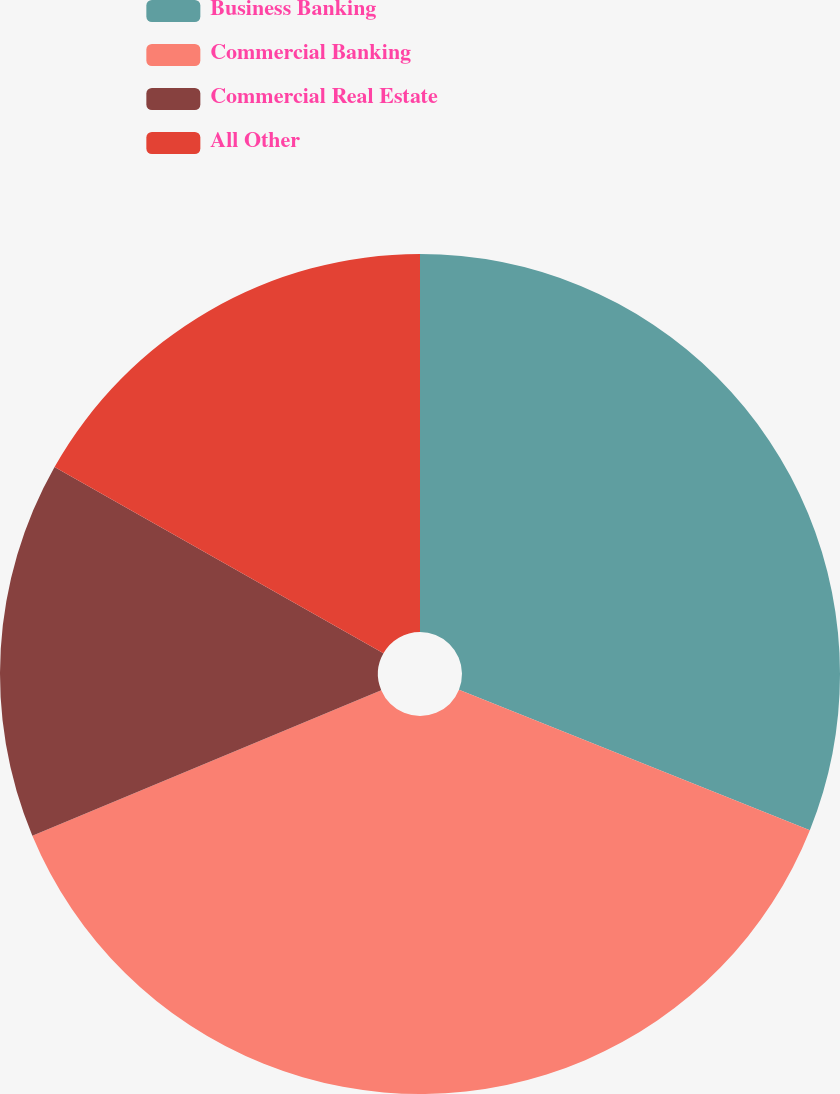Convert chart to OTSL. <chart><loc_0><loc_0><loc_500><loc_500><pie_chart><fcel>Business Banking<fcel>Commercial Banking<fcel>Commercial Real Estate<fcel>All Other<nl><fcel>31.07%<fcel>37.65%<fcel>14.49%<fcel>16.8%<nl></chart> 